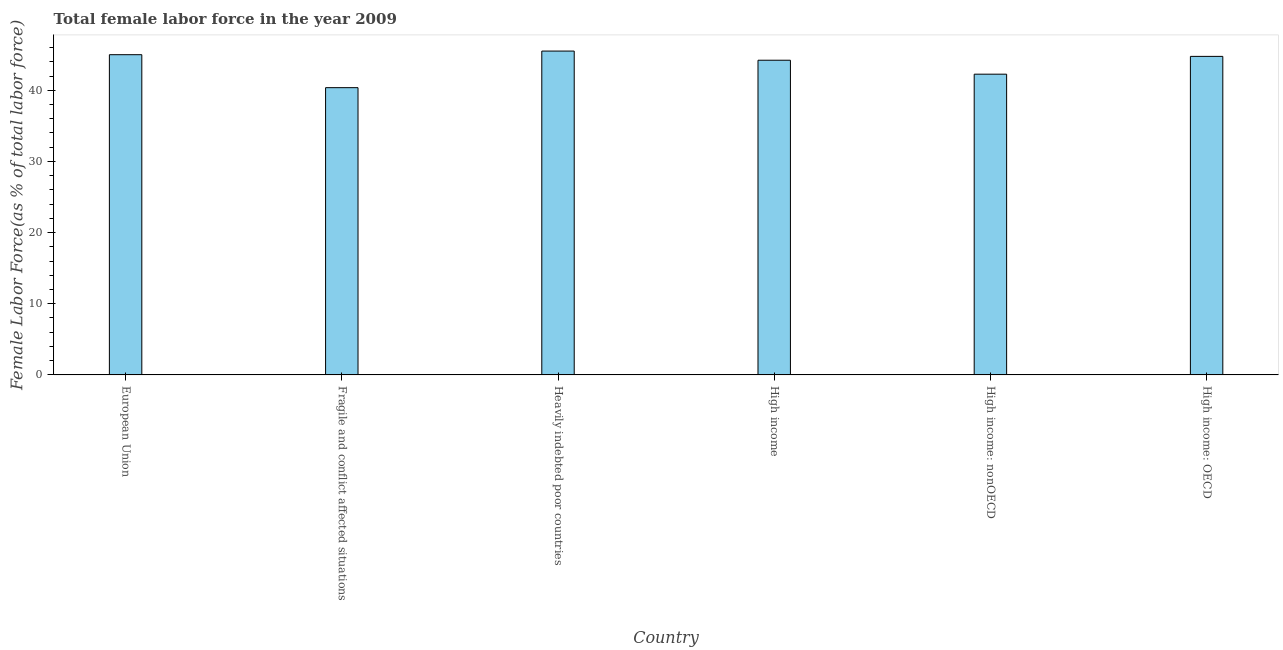What is the title of the graph?
Provide a short and direct response. Total female labor force in the year 2009. What is the label or title of the Y-axis?
Ensure brevity in your answer.  Female Labor Force(as % of total labor force). What is the total female labor force in Heavily indebted poor countries?
Ensure brevity in your answer.  45.51. Across all countries, what is the maximum total female labor force?
Your response must be concise. 45.51. Across all countries, what is the minimum total female labor force?
Your answer should be compact. 40.37. In which country was the total female labor force maximum?
Provide a succinct answer. Heavily indebted poor countries. In which country was the total female labor force minimum?
Ensure brevity in your answer.  Fragile and conflict affected situations. What is the sum of the total female labor force?
Your answer should be very brief. 262.15. What is the difference between the total female labor force in European Union and Heavily indebted poor countries?
Provide a succinct answer. -0.51. What is the average total female labor force per country?
Offer a terse response. 43.69. What is the median total female labor force?
Offer a very short reply. 44.5. In how many countries, is the total female labor force greater than 16 %?
Provide a short and direct response. 6. What is the ratio of the total female labor force in European Union to that in High income?
Make the answer very short. 1.02. Is the total female labor force in Fragile and conflict affected situations less than that in High income: nonOECD?
Make the answer very short. Yes. Is the difference between the total female labor force in Heavily indebted poor countries and High income: OECD greater than the difference between any two countries?
Ensure brevity in your answer.  No. What is the difference between the highest and the second highest total female labor force?
Your answer should be very brief. 0.51. Is the sum of the total female labor force in High income: OECD and High income: nonOECD greater than the maximum total female labor force across all countries?
Make the answer very short. Yes. What is the difference between the highest and the lowest total female labor force?
Your response must be concise. 5.14. In how many countries, is the total female labor force greater than the average total female labor force taken over all countries?
Your answer should be compact. 4. How many bars are there?
Give a very brief answer. 6. Are the values on the major ticks of Y-axis written in scientific E-notation?
Your answer should be compact. No. What is the Female Labor Force(as % of total labor force) of European Union?
Your answer should be very brief. 45. What is the Female Labor Force(as % of total labor force) in Fragile and conflict affected situations?
Keep it short and to the point. 40.37. What is the Female Labor Force(as % of total labor force) of Heavily indebted poor countries?
Provide a succinct answer. 45.51. What is the Female Labor Force(as % of total labor force) in High income?
Provide a short and direct response. 44.23. What is the Female Labor Force(as % of total labor force) of High income: nonOECD?
Provide a short and direct response. 42.27. What is the Female Labor Force(as % of total labor force) in High income: OECD?
Give a very brief answer. 44.77. What is the difference between the Female Labor Force(as % of total labor force) in European Union and Fragile and conflict affected situations?
Ensure brevity in your answer.  4.63. What is the difference between the Female Labor Force(as % of total labor force) in European Union and Heavily indebted poor countries?
Offer a terse response. -0.51. What is the difference between the Female Labor Force(as % of total labor force) in European Union and High income?
Keep it short and to the point. 0.78. What is the difference between the Female Labor Force(as % of total labor force) in European Union and High income: nonOECD?
Provide a short and direct response. 2.74. What is the difference between the Female Labor Force(as % of total labor force) in European Union and High income: OECD?
Make the answer very short. 0.24. What is the difference between the Female Labor Force(as % of total labor force) in Fragile and conflict affected situations and Heavily indebted poor countries?
Your response must be concise. -5.14. What is the difference between the Female Labor Force(as % of total labor force) in Fragile and conflict affected situations and High income?
Ensure brevity in your answer.  -3.86. What is the difference between the Female Labor Force(as % of total labor force) in Fragile and conflict affected situations and High income: nonOECD?
Give a very brief answer. -1.89. What is the difference between the Female Labor Force(as % of total labor force) in Fragile and conflict affected situations and High income: OECD?
Your response must be concise. -4.4. What is the difference between the Female Labor Force(as % of total labor force) in Heavily indebted poor countries and High income?
Offer a terse response. 1.29. What is the difference between the Female Labor Force(as % of total labor force) in Heavily indebted poor countries and High income: nonOECD?
Offer a very short reply. 3.25. What is the difference between the Female Labor Force(as % of total labor force) in Heavily indebted poor countries and High income: OECD?
Ensure brevity in your answer.  0.75. What is the difference between the Female Labor Force(as % of total labor force) in High income and High income: nonOECD?
Provide a short and direct response. 1.96. What is the difference between the Female Labor Force(as % of total labor force) in High income and High income: OECD?
Provide a short and direct response. -0.54. What is the difference between the Female Labor Force(as % of total labor force) in High income: nonOECD and High income: OECD?
Ensure brevity in your answer.  -2.5. What is the ratio of the Female Labor Force(as % of total labor force) in European Union to that in Fragile and conflict affected situations?
Your answer should be compact. 1.11. What is the ratio of the Female Labor Force(as % of total labor force) in European Union to that in High income: nonOECD?
Offer a very short reply. 1.06. What is the ratio of the Female Labor Force(as % of total labor force) in Fragile and conflict affected situations to that in Heavily indebted poor countries?
Ensure brevity in your answer.  0.89. What is the ratio of the Female Labor Force(as % of total labor force) in Fragile and conflict affected situations to that in High income: nonOECD?
Your response must be concise. 0.95. What is the ratio of the Female Labor Force(as % of total labor force) in Fragile and conflict affected situations to that in High income: OECD?
Provide a short and direct response. 0.9. What is the ratio of the Female Labor Force(as % of total labor force) in Heavily indebted poor countries to that in High income?
Your answer should be very brief. 1.03. What is the ratio of the Female Labor Force(as % of total labor force) in Heavily indebted poor countries to that in High income: nonOECD?
Offer a very short reply. 1.08. What is the ratio of the Female Labor Force(as % of total labor force) in High income to that in High income: nonOECD?
Your answer should be compact. 1.05. What is the ratio of the Female Labor Force(as % of total labor force) in High income: nonOECD to that in High income: OECD?
Provide a short and direct response. 0.94. 